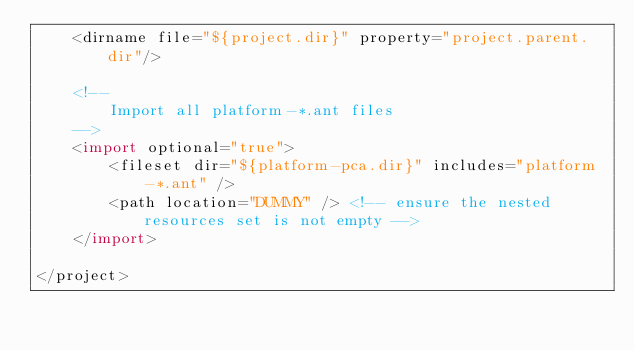Convert code to text. <code><loc_0><loc_0><loc_500><loc_500><_XML_>	<dirname file="${project.dir}" property="project.parent.dir"/>

	<!--
		Import all platform-*.ant files
	-->
	<import optional="true">
		<fileset dir="${platform-pca.dir}" includes="platform-*.ant" />
		<path location="DUMMY" /> <!-- ensure the nested resources set is not empty -->
	</import>
	
</project>
</code> 